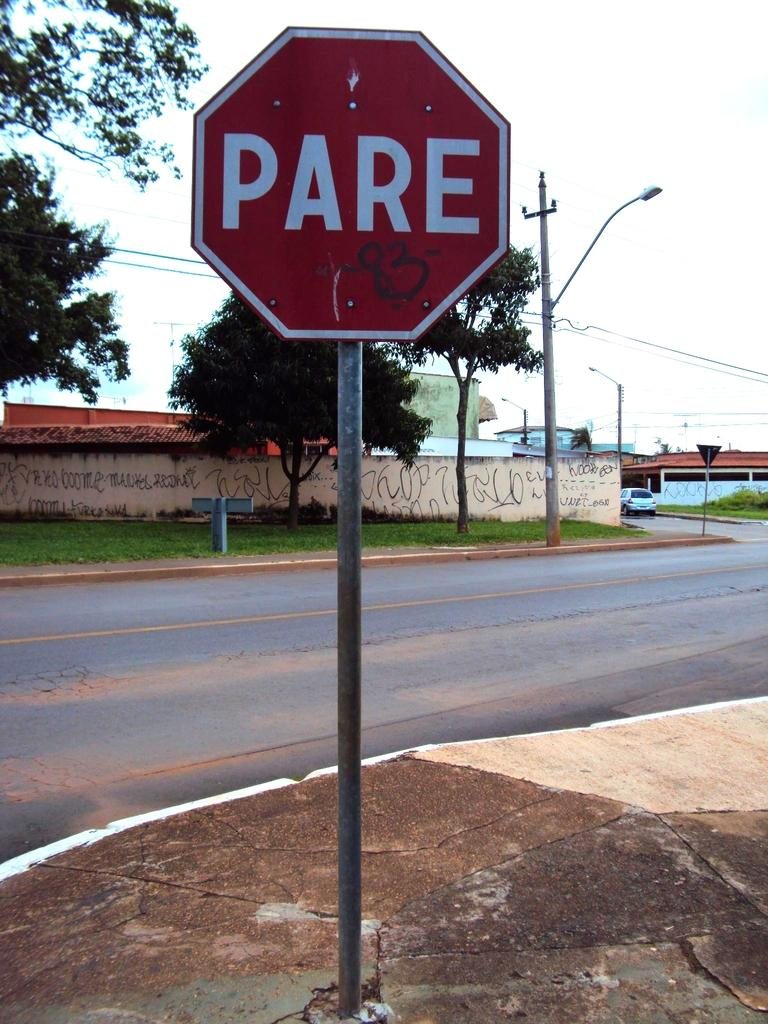Provide a one-sentence caption for the provided image. A red sign with white letters spelling PARE. 